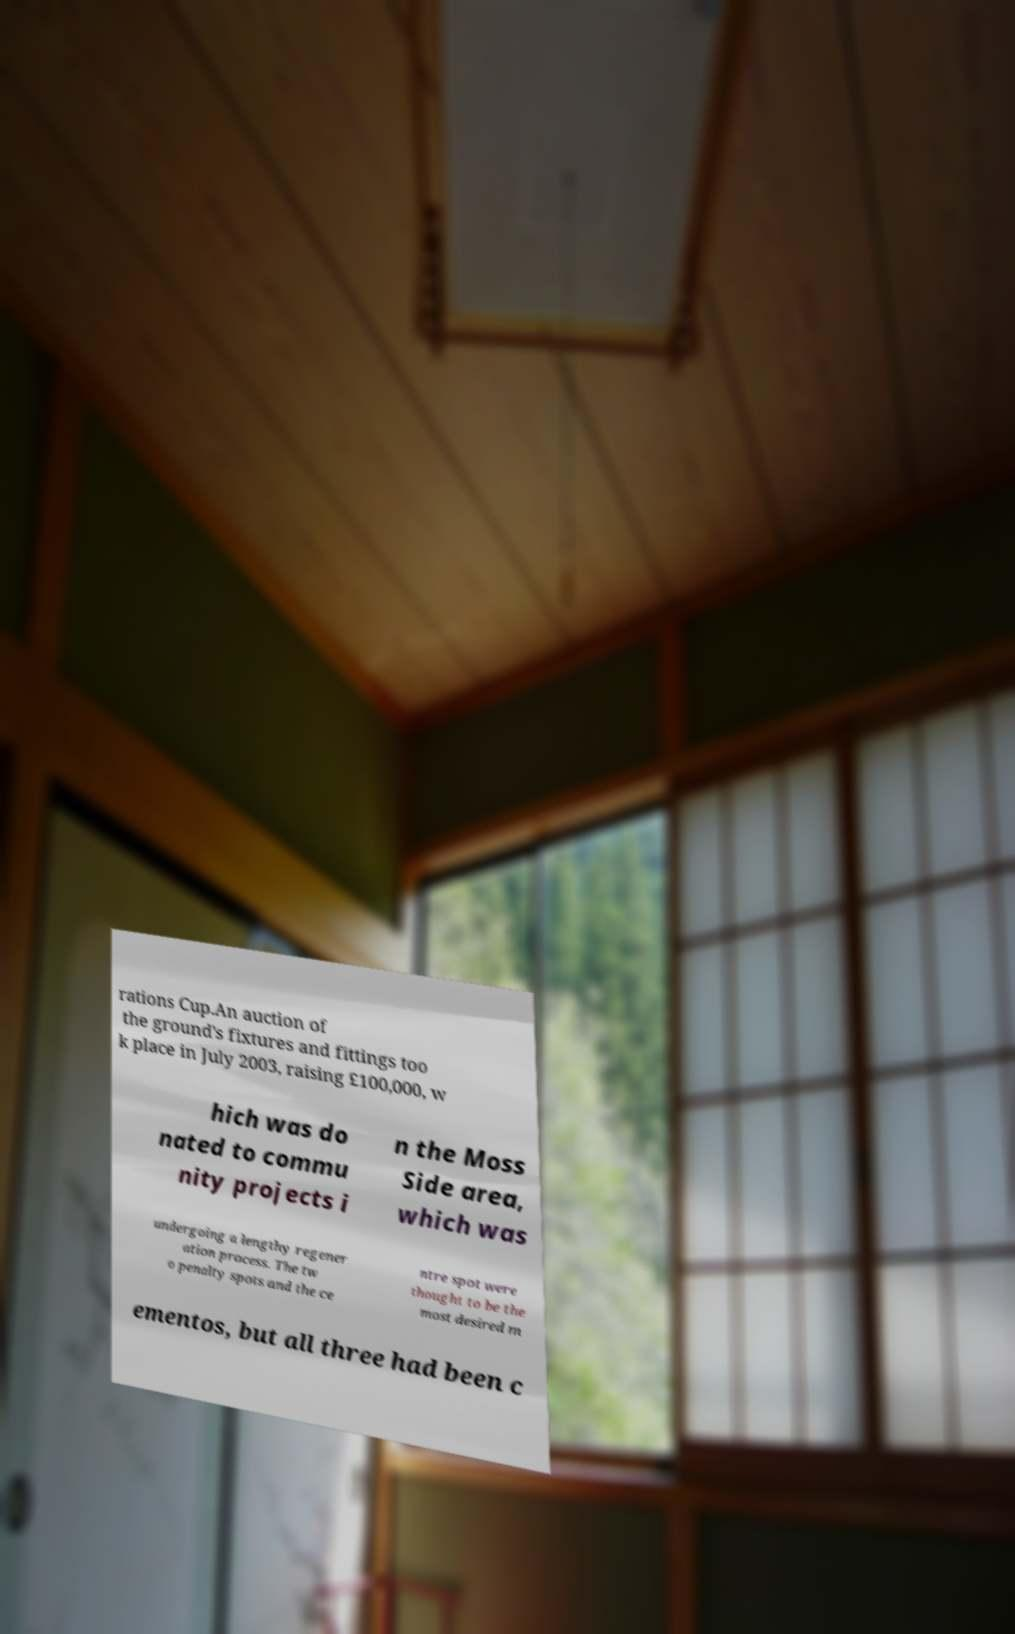Could you extract and type out the text from this image? rations Cup.An auction of the ground's fixtures and fittings too k place in July 2003, raising £100,000, w hich was do nated to commu nity projects i n the Moss Side area, which was undergoing a lengthy regener ation process. The tw o penalty spots and the ce ntre spot were thought to be the most desired m ementos, but all three had been c 